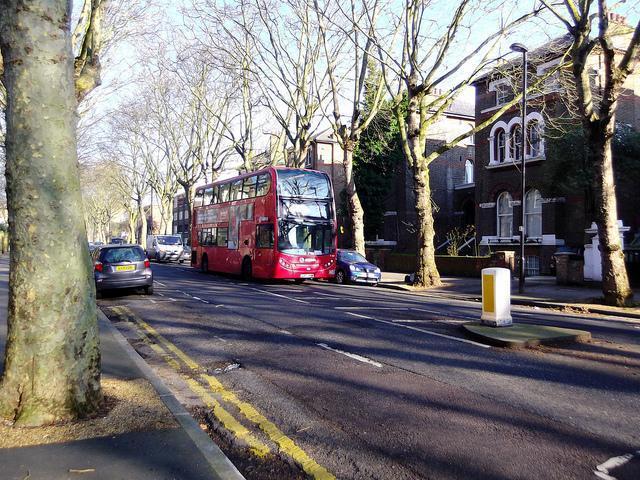How many buses can be seen?
Give a very brief answer. 1. How many bike on this image?
Give a very brief answer. 0. 